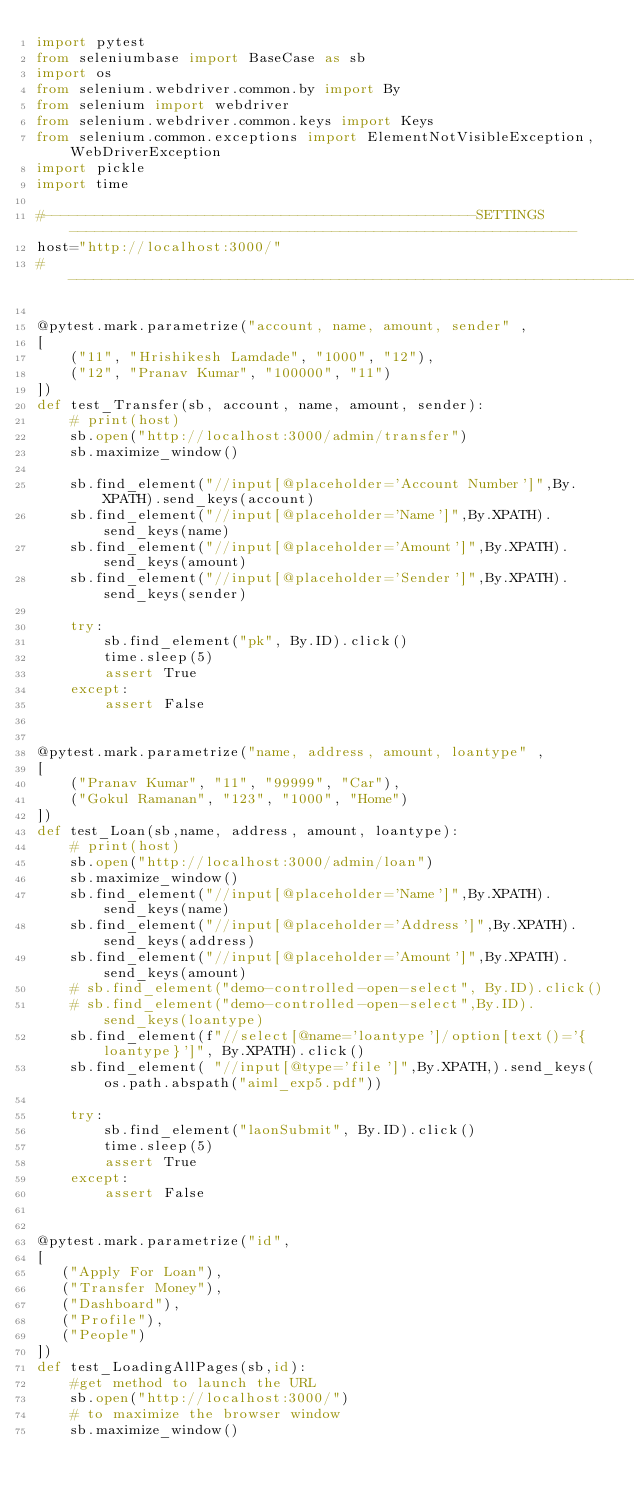<code> <loc_0><loc_0><loc_500><loc_500><_Python_>import pytest
from seleniumbase import BaseCase as sb
import os
from selenium.webdriver.common.by import By
from selenium import webdriver
from selenium.webdriver.common.keys import Keys
from selenium.common.exceptions import ElementNotVisibleException, WebDriverException
import pickle
import time

#---------------------------------------------------SETTINGS------------------------------------------------------------
host="http://localhost:3000/"
#-----------------------------------------------------------------------------------------------------------------------

@pytest.mark.parametrize("account, name, amount, sender" ,
[
    ("11", "Hrishikesh Lamdade", "1000", "12"),
    ("12", "Pranav Kumar", "100000", "11")
])
def test_Transfer(sb, account, name, amount, sender):
    # print(host)
    sb.open("http://localhost:3000/admin/transfer")
    sb.maximize_window()

    sb.find_element("//input[@placeholder='Account Number']",By.XPATH).send_keys(account)
    sb.find_element("//input[@placeholder='Name']",By.XPATH).send_keys(name)
    sb.find_element("//input[@placeholder='Amount']",By.XPATH).send_keys(amount)
    sb.find_element("//input[@placeholder='Sender']",By.XPATH).send_keys(sender)

    try:
        sb.find_element("pk", By.ID).click()
        time.sleep(5)
        assert True
    except:
        assert False


@pytest.mark.parametrize("name, address, amount, loantype" ,
[
    ("Pranav Kumar", "11", "99999", "Car"),
    ("Gokul Ramanan", "123", "1000", "Home")
])
def test_Loan(sb,name, address, amount, loantype):
    # print(host)
    sb.open("http://localhost:3000/admin/loan")
    sb.maximize_window()
    sb.find_element("//input[@placeholder='Name']",By.XPATH).send_keys(name)
    sb.find_element("//input[@placeholder='Address']",By.XPATH).send_keys(address)
    sb.find_element("//input[@placeholder='Amount']",By.XPATH).send_keys(amount)
    # sb.find_element("demo-controlled-open-select", By.ID).click()
    # sb.find_element("demo-controlled-open-select",By.ID).send_keys(loantype)
    sb.find_element(f"//select[@name='loantype']/option[text()='{loantype}']", By.XPATH).click()
    sb.find_element( "//input[@type='file']",By.XPATH,).send_keys(os.path.abspath("aiml_exp5.pdf"))
    
    try:
        sb.find_element("laonSubmit", By.ID).click()
        time.sleep(5)
        assert True
    except:
        assert False


@pytest.mark.parametrize("id",
[
   ("Apply For Loan"),
   ("Transfer Money"),
   ("Dashboard"),
   ("Profile"),
   ("People")
])
def test_LoadingAllPages(sb,id):
    #get method to launch the URL
    sb.open("http://localhost:3000/")
    # to maximize the browser window
    sb.maximize_window()</code> 